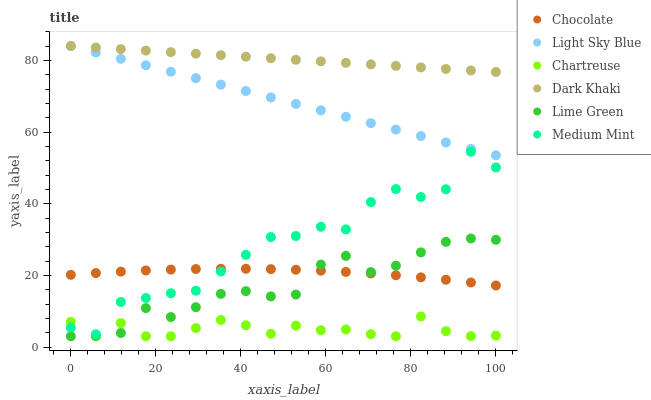Does Chartreuse have the minimum area under the curve?
Answer yes or no. Yes. Does Dark Khaki have the maximum area under the curve?
Answer yes or no. Yes. Does Chocolate have the minimum area under the curve?
Answer yes or no. No. Does Chocolate have the maximum area under the curve?
Answer yes or no. No. Is Light Sky Blue the smoothest?
Answer yes or no. Yes. Is Medium Mint the roughest?
Answer yes or no. Yes. Is Chocolate the smoothest?
Answer yes or no. No. Is Chocolate the roughest?
Answer yes or no. No. Does Chartreuse have the lowest value?
Answer yes or no. Yes. Does Chocolate have the lowest value?
Answer yes or no. No. Does Light Sky Blue have the highest value?
Answer yes or no. Yes. Does Chocolate have the highest value?
Answer yes or no. No. Is Medium Mint less than Light Sky Blue?
Answer yes or no. Yes. Is Light Sky Blue greater than Lime Green?
Answer yes or no. Yes. Does Chocolate intersect Medium Mint?
Answer yes or no. Yes. Is Chocolate less than Medium Mint?
Answer yes or no. No. Is Chocolate greater than Medium Mint?
Answer yes or no. No. Does Medium Mint intersect Light Sky Blue?
Answer yes or no. No. 